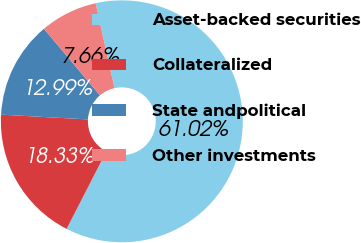Convert chart. <chart><loc_0><loc_0><loc_500><loc_500><pie_chart><fcel>Asset-backed securities<fcel>Collateralized<fcel>State andpolitical<fcel>Other investments<nl><fcel>61.02%<fcel>18.33%<fcel>12.99%<fcel>7.66%<nl></chart> 